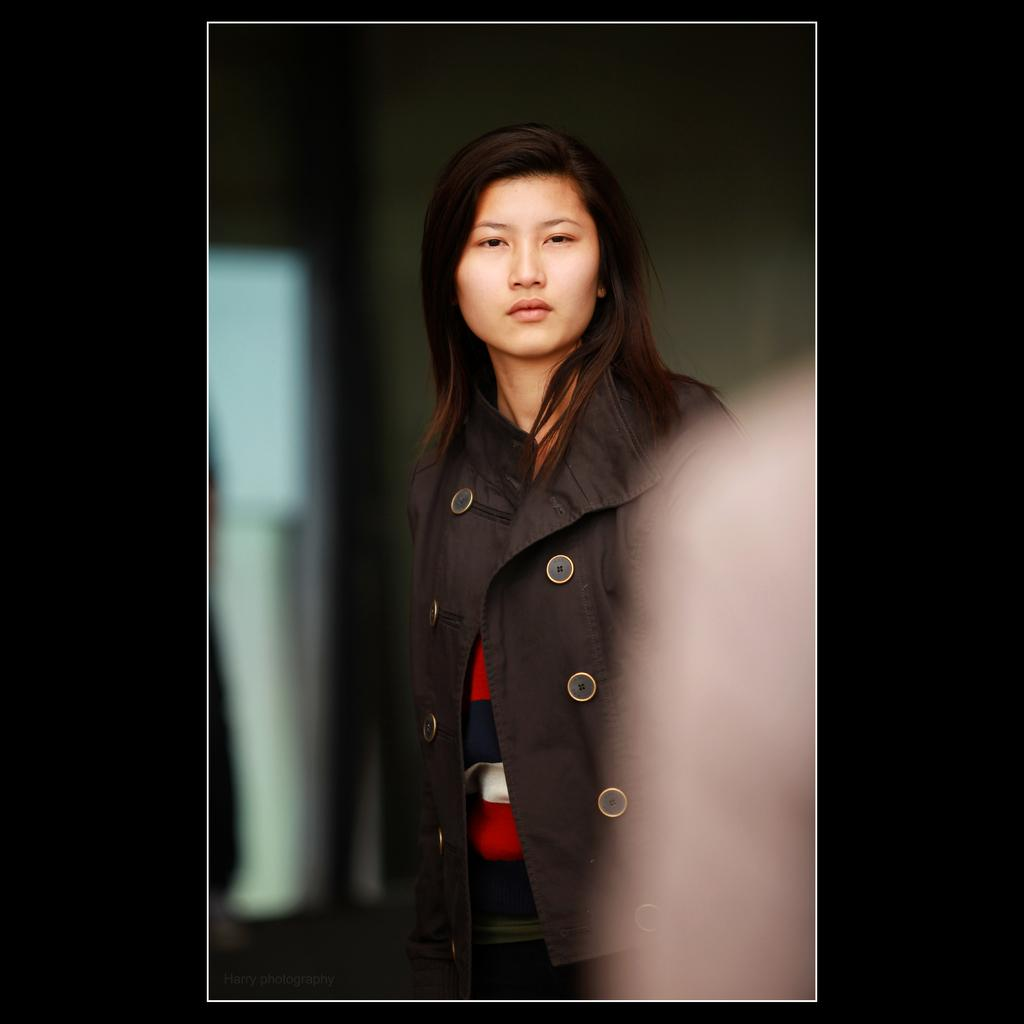Who is the main subject in the center of the picture? There is a woman in the center of the picture. What is the woman wearing in the image? The woman is wearing a black jacket. How is the picture framed? The picture has a black border. What can be observed about the background of the image? The background of the image is blurred. What else is visible in the image besides the woman? There is a person's hand on the right side of the image. What flavor of ice cream is being advertised in the image? There is no ice cream or advertisement present in the image. Can you tell me the birth date of the woman in the image? The image does not provide any information about the woman's birth date. 